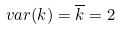<formula> <loc_0><loc_0><loc_500><loc_500>v a r ( k ) = \overline { k } = 2</formula> 